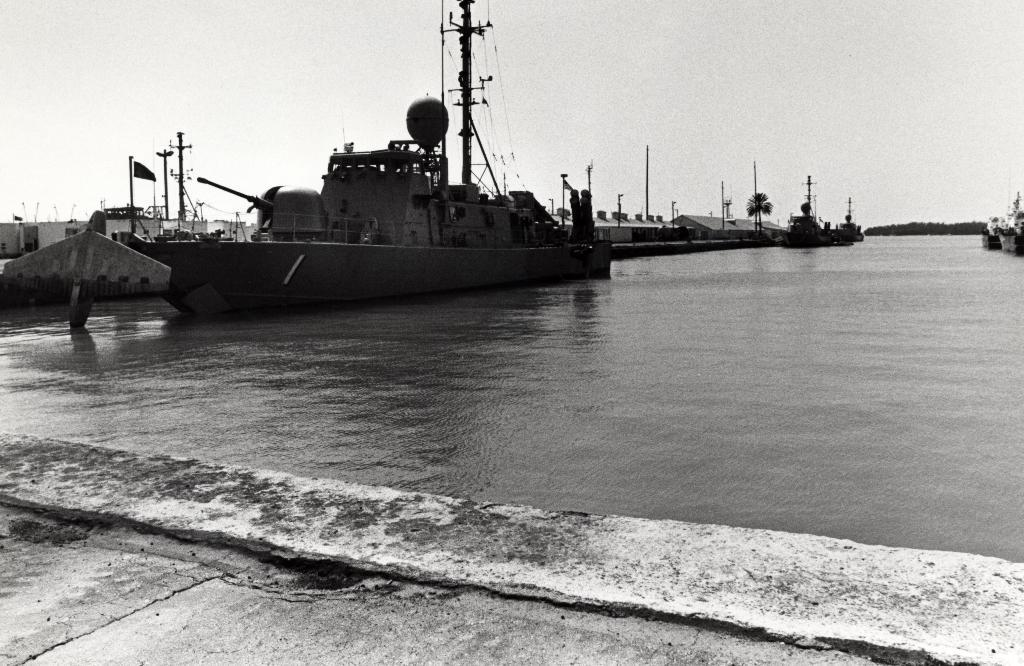What is the main subject in the center of the image? There is water in the center of the image. What can be seen on the left side of the image? There is a ship on the left side of the image, and warehouses are also present on the left side. How is the ship positioned in relation to the water? The ship is on the water in the image. What type of instrument is being played by the achiever in the image? There is no achiever or instrument present in the image. How does the dust settle on the water in the image? There is no dust present in the image; it only features water, a ship, and warehouses. 